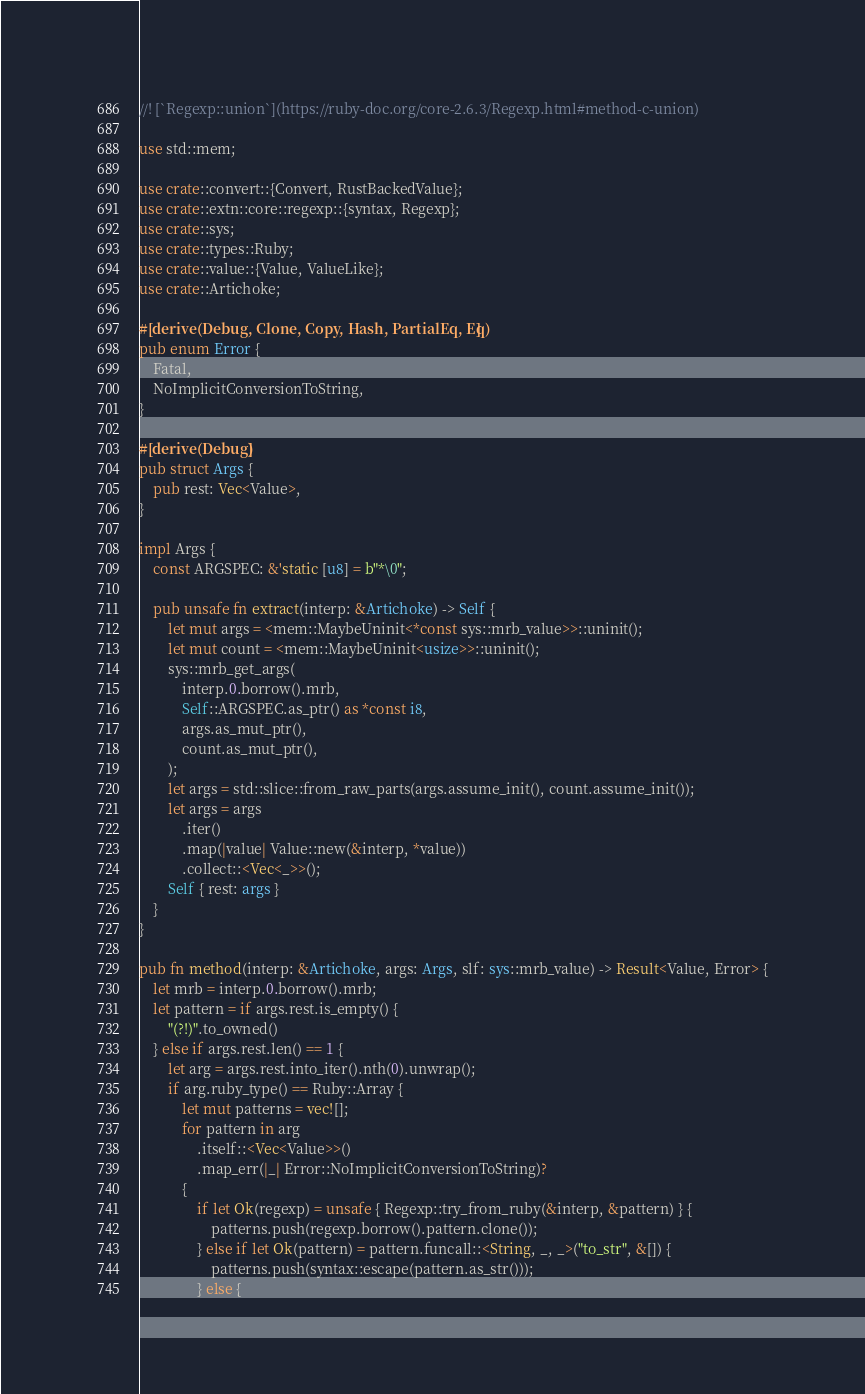Convert code to text. <code><loc_0><loc_0><loc_500><loc_500><_Rust_>//! [`Regexp::union`](https://ruby-doc.org/core-2.6.3/Regexp.html#method-c-union)

use std::mem;

use crate::convert::{Convert, RustBackedValue};
use crate::extn::core::regexp::{syntax, Regexp};
use crate::sys;
use crate::types::Ruby;
use crate::value::{Value, ValueLike};
use crate::Artichoke;

#[derive(Debug, Clone, Copy, Hash, PartialEq, Eq)]
pub enum Error {
    Fatal,
    NoImplicitConversionToString,
}

#[derive(Debug)]
pub struct Args {
    pub rest: Vec<Value>,
}

impl Args {
    const ARGSPEC: &'static [u8] = b"*\0";

    pub unsafe fn extract(interp: &Artichoke) -> Self {
        let mut args = <mem::MaybeUninit<*const sys::mrb_value>>::uninit();
        let mut count = <mem::MaybeUninit<usize>>::uninit();
        sys::mrb_get_args(
            interp.0.borrow().mrb,
            Self::ARGSPEC.as_ptr() as *const i8,
            args.as_mut_ptr(),
            count.as_mut_ptr(),
        );
        let args = std::slice::from_raw_parts(args.assume_init(), count.assume_init());
        let args = args
            .iter()
            .map(|value| Value::new(&interp, *value))
            .collect::<Vec<_>>();
        Self { rest: args }
    }
}

pub fn method(interp: &Artichoke, args: Args, slf: sys::mrb_value) -> Result<Value, Error> {
    let mrb = interp.0.borrow().mrb;
    let pattern = if args.rest.is_empty() {
        "(?!)".to_owned()
    } else if args.rest.len() == 1 {
        let arg = args.rest.into_iter().nth(0).unwrap();
        if arg.ruby_type() == Ruby::Array {
            let mut patterns = vec![];
            for pattern in arg
                .itself::<Vec<Value>>()
                .map_err(|_| Error::NoImplicitConversionToString)?
            {
                if let Ok(regexp) = unsafe { Regexp::try_from_ruby(&interp, &pattern) } {
                    patterns.push(regexp.borrow().pattern.clone());
                } else if let Ok(pattern) = pattern.funcall::<String, _, _>("to_str", &[]) {
                    patterns.push(syntax::escape(pattern.as_str()));
                } else {</code> 